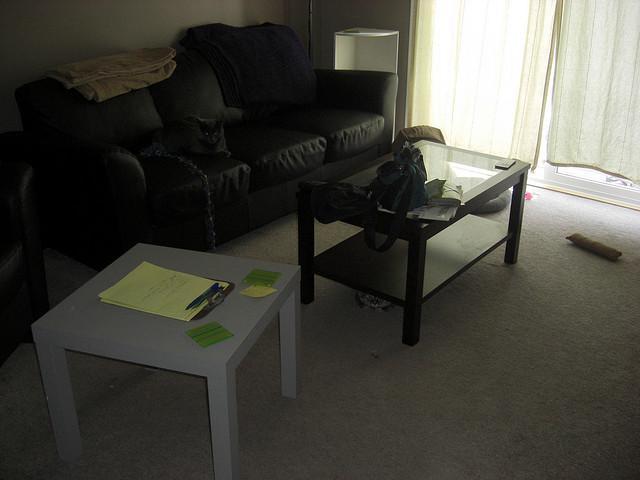How many handbags are there?
Give a very brief answer. 1. How many dining tables are in the photo?
Give a very brief answer. 2. How many people are to the left of the person standing?
Give a very brief answer. 0. 